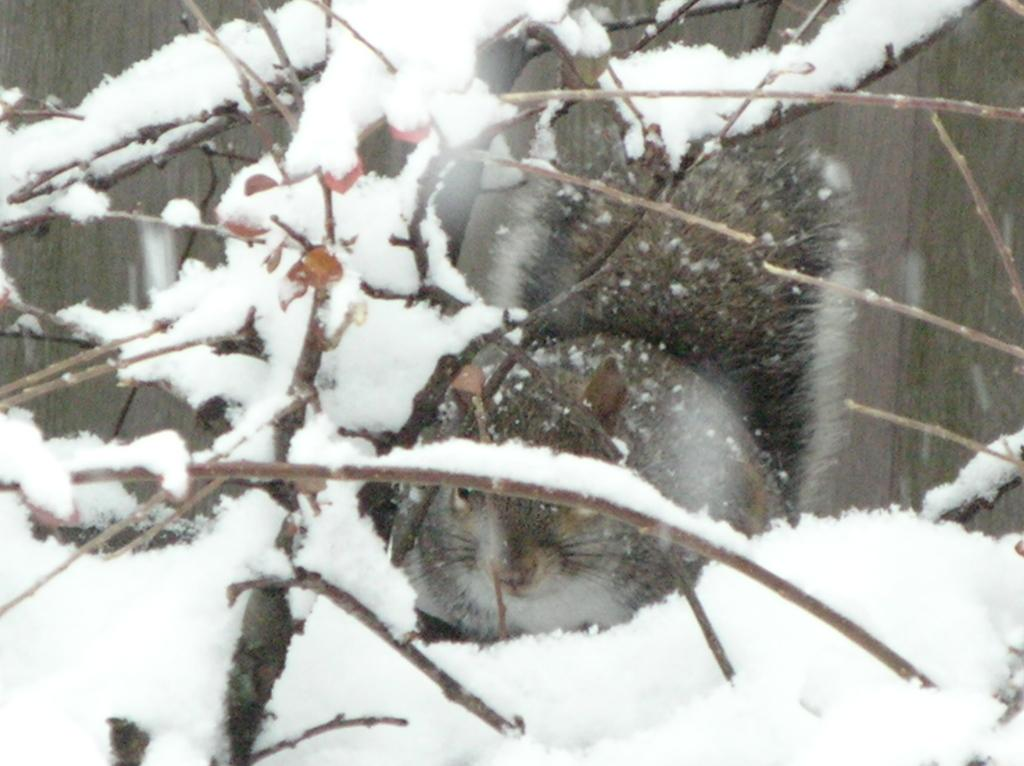What type of animal can be seen in the image? There is an animal in the image, but we cannot determine the specific type without more information. What else is visible in the image besides the animal? There are stems visible in the image. What is the ground made of in the image? The ground is covered in white snow in the image. How many balloons are tied to the rail in the image? There are no balloons or rails present in the image. What type of brush is being used to clean the animal in the image? There is no brush or cleaning activity depicted in the image. 